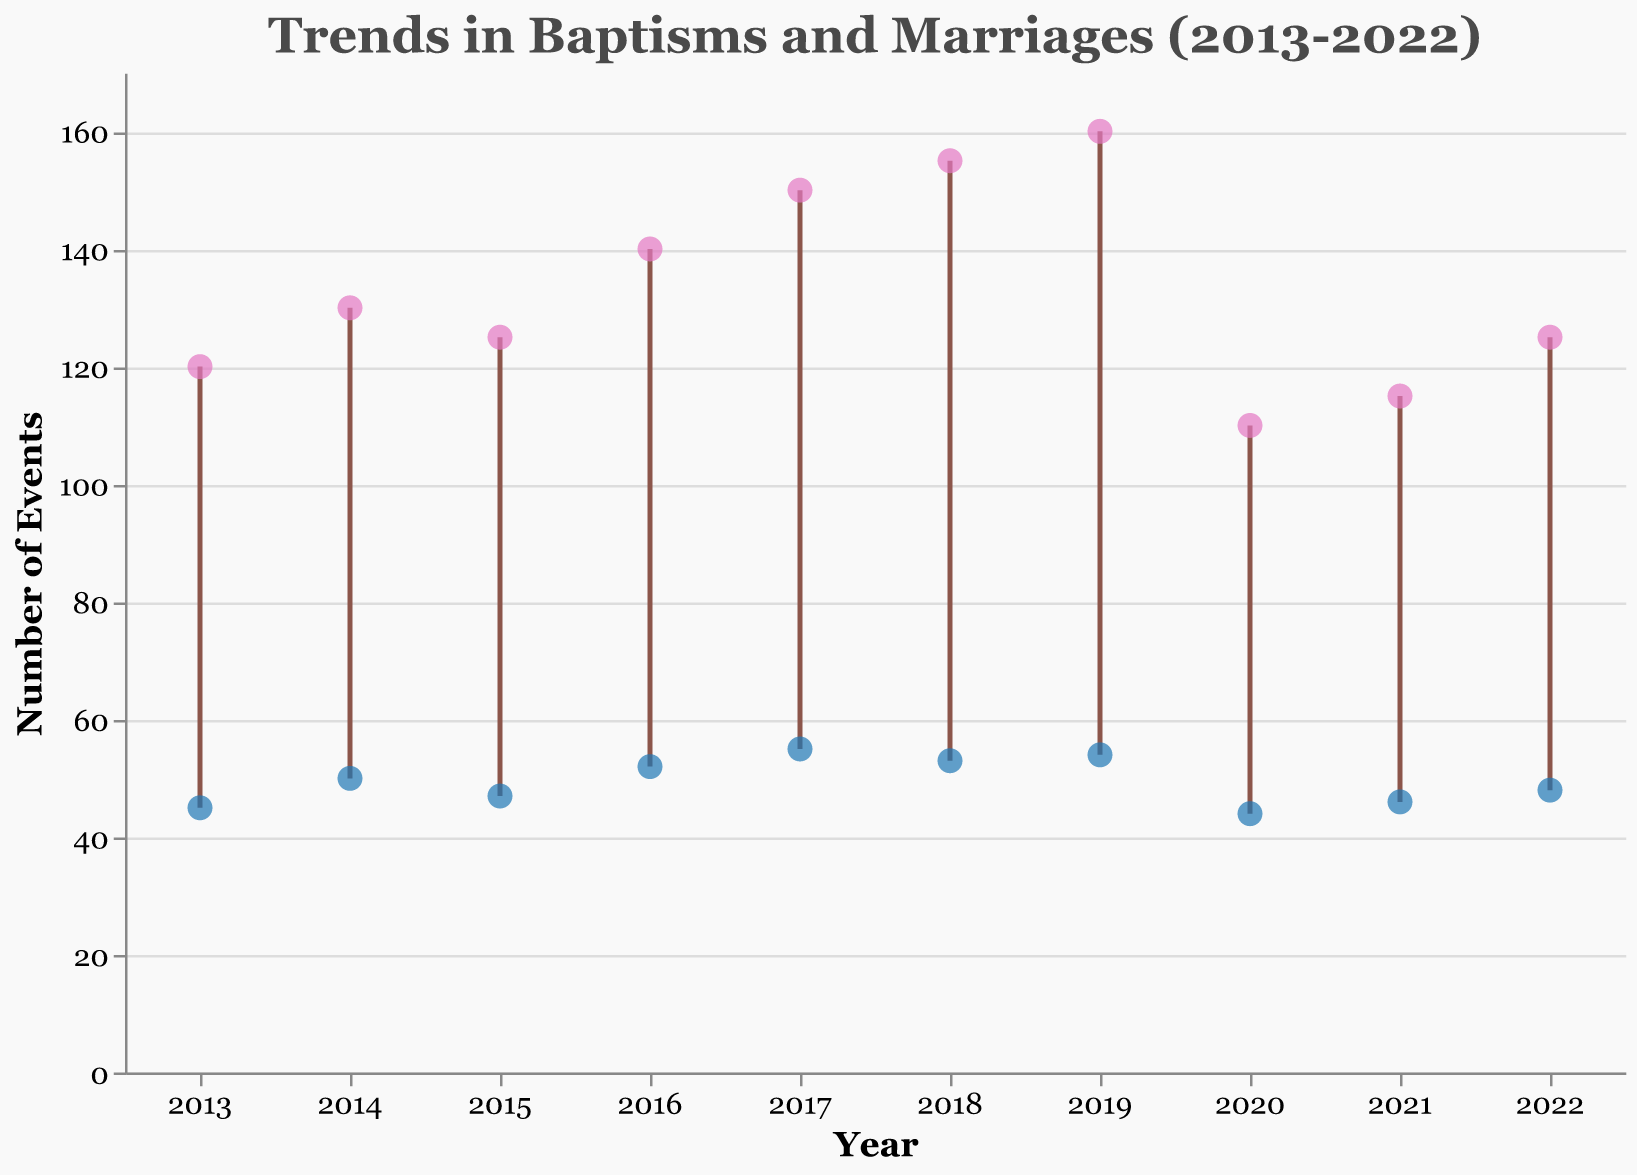What is the title of the figure? The title of the figure can be found at the top and is designed to describe the main topic of the plot.
Answer: Trends in Baptisms and Marriages (2013-2022) What are the trends in baptisms from 2013 to 2022? To identify the trends in baptisms, observe the points indicated by the filled markers and the overall slope of the connecting lines for "Baptisms" over the years. The figure shows an increase from 2013 to 2019, followed by a drop in 2020, and then a slight recovery from 2021 to 2022.
Answer: Upward trend until 2019, then a drop in 2020, followed by a recovery Which year had the lowest number of baptisms? Look at the vertical positions of the "Baptisms" points. The year with the lowest point on the y-axis for baptisms indicates the lowest number. 2020 had the lowest number of baptisms.
Answer: 2020 How many more baptisms were there than marriages in 2017? Identify the points for 2017. Subtract the number of marriages from the number of baptisms for that year. Baptisms: 150, Marriages: 55, Difference: 150 - 55 = 95.
Answer: 95 During which years were the number of baptisms and marriages closest to each other? Compare the distances between the "Baptisms" and "Marriages" points for each year. The shortest vertical distance indicates the closest numbers. 2013 saw the smallest gap between 120 baptisms and 45 marriages. The most significant discrepancy is also in 2020 and later years.
Answer: 2020 What is the overall trend in the number of marriages from 2013 to 2022? Observe the "Marriages" points over the years. While there is a general upward trend with some fluctuations, there is a slight decrease in 2020, and then the values start to rise again.
Answer: Upward trend with slight fluctuations, decrease in 2020, and then a rise How many more events (baptisms plus marriages) were there in 2018 compared to 2021? Calculate the sum of baptisms and marriages for both years and then find the difference between those sums. 2018: 155 + 53 = 208; 2021: 115 + 46 = 161; Difference: 208 - 161 = 47.
Answer: 47 Which year showed the highest number of baptisms? Look at the "Baptisms" points and find the one at the highest vertical position. The year 2019 has the highest vertical position at 160 baptisms.
Answer: 2019 What was the difference in the number of marriages between 2015 and 2018? Identify the "Marriages" points for both years and subtract the number for 2015 from 2018. 2018: 53, 2015: 47, Difference: 53 - 47 = 6.
Answer: 6 Is there any year where the number of marriages surpassed 55? Observe the highest vertical positions of the "Marriages" points. The data shows that no year had marriages surpassing 55. The highest recorded was 55 in both 2017 and 2019.
Answer: No 